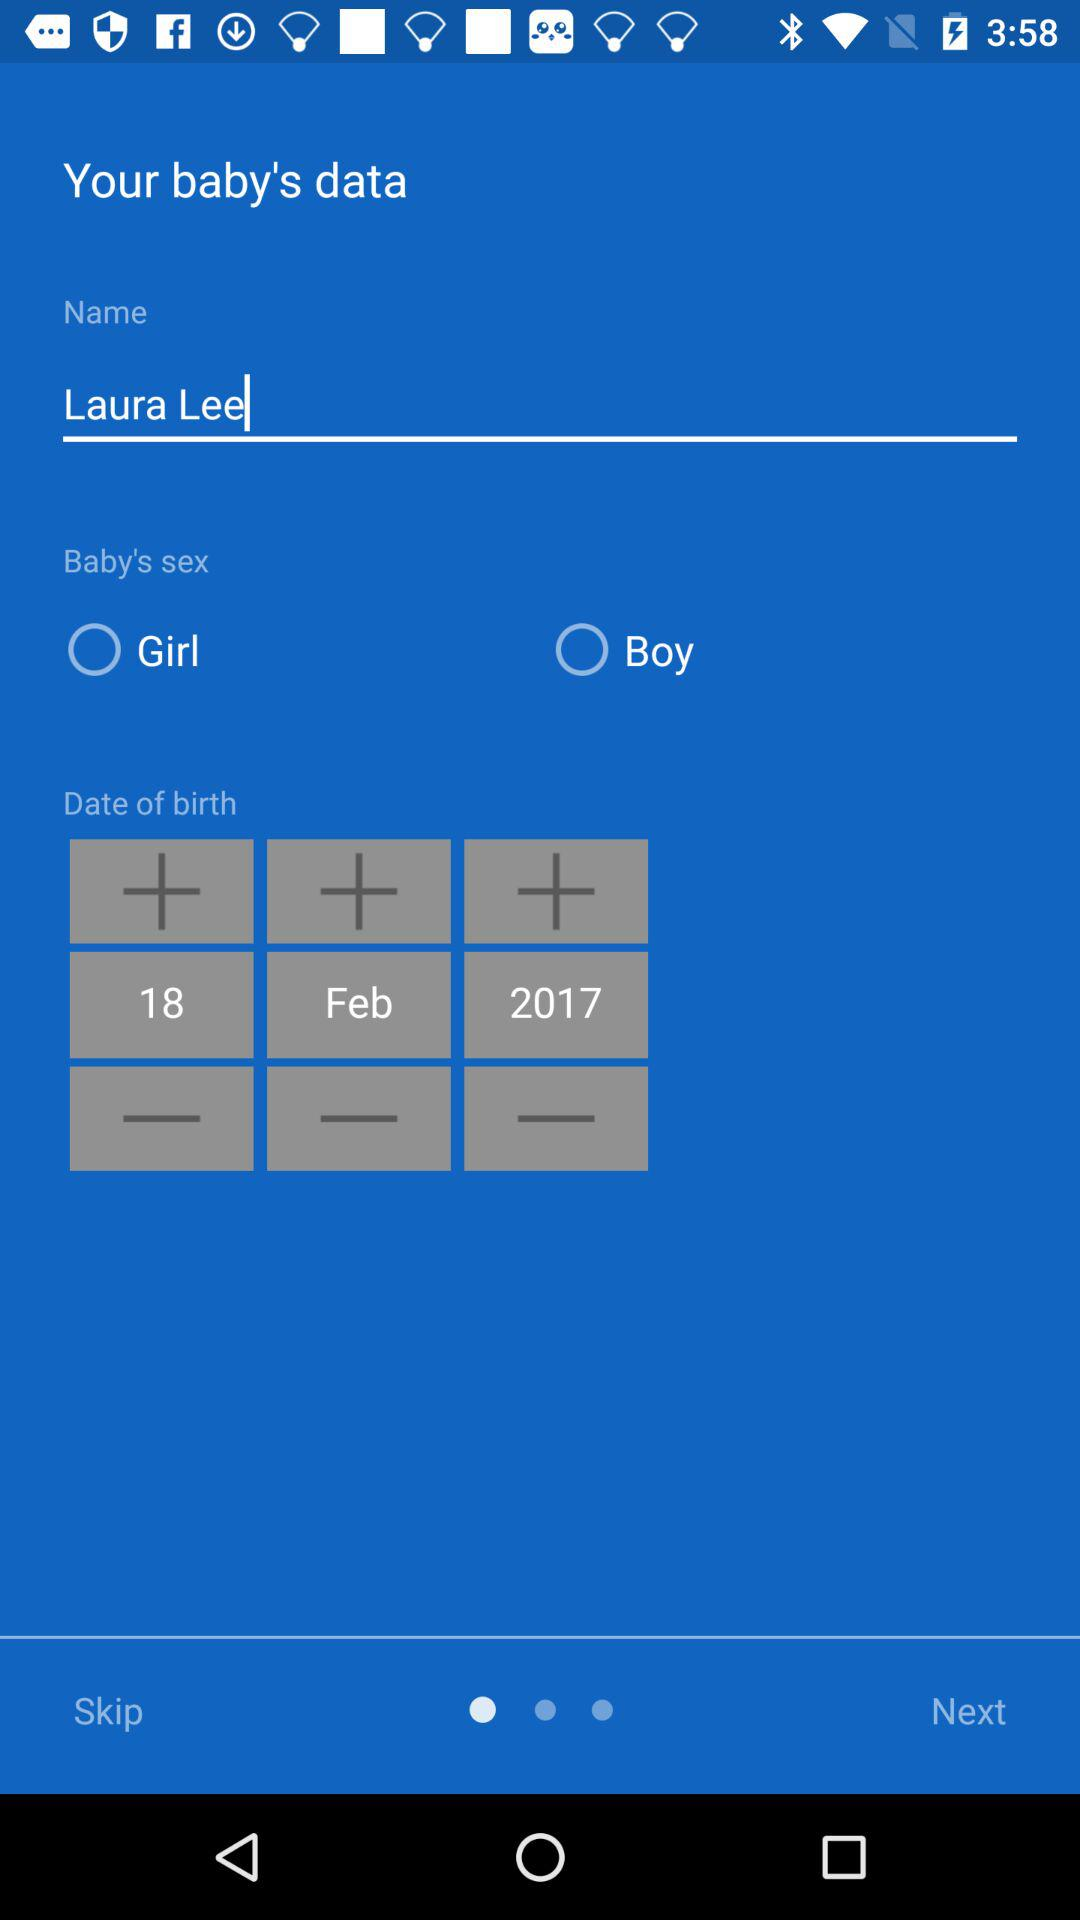What is the date of birth? The date of birth is February 18, 2017. 